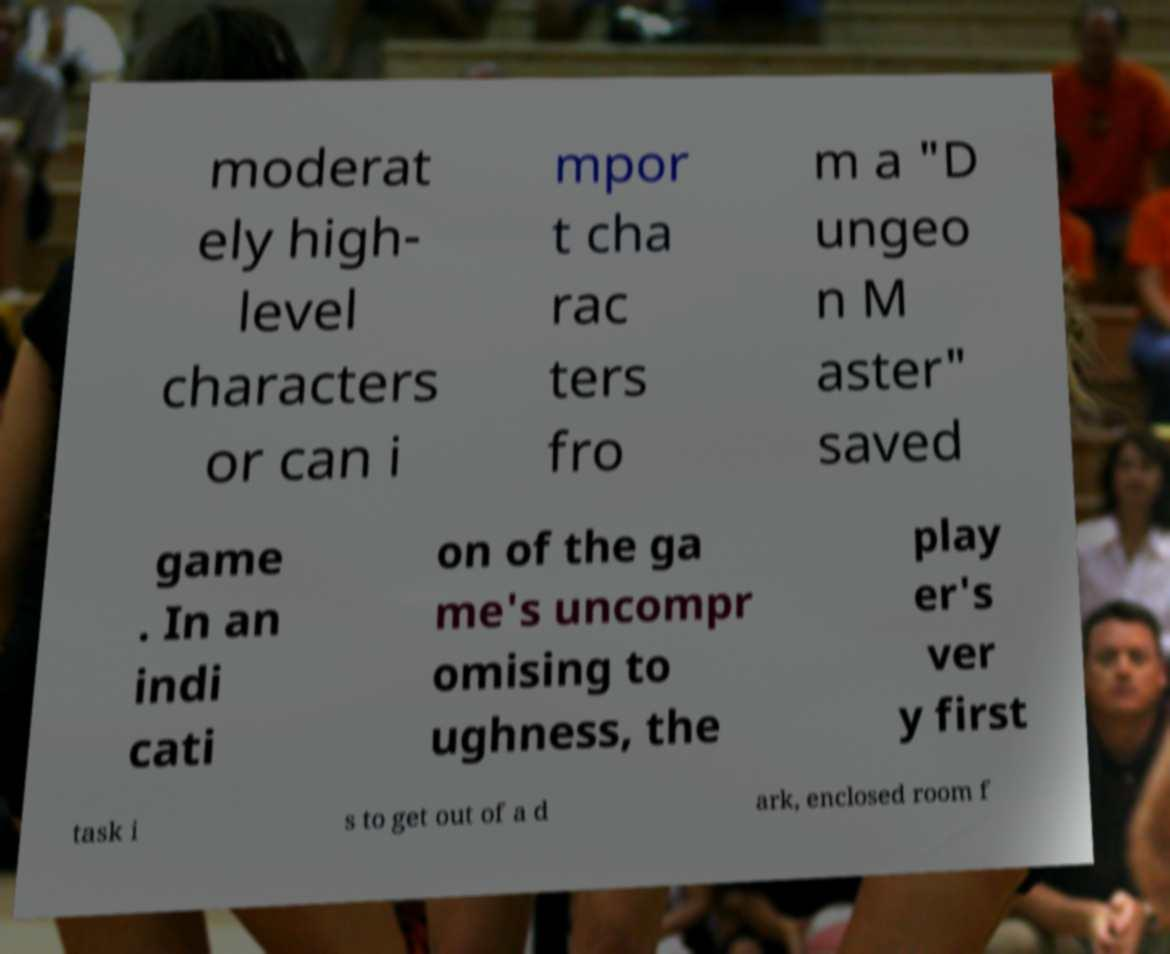Please identify and transcribe the text found in this image. moderat ely high- level characters or can i mpor t cha rac ters fro m a "D ungeo n M aster" saved game . In an indi cati on of the ga me's uncompr omising to ughness, the play er's ver y first task i s to get out of a d ark, enclosed room f 